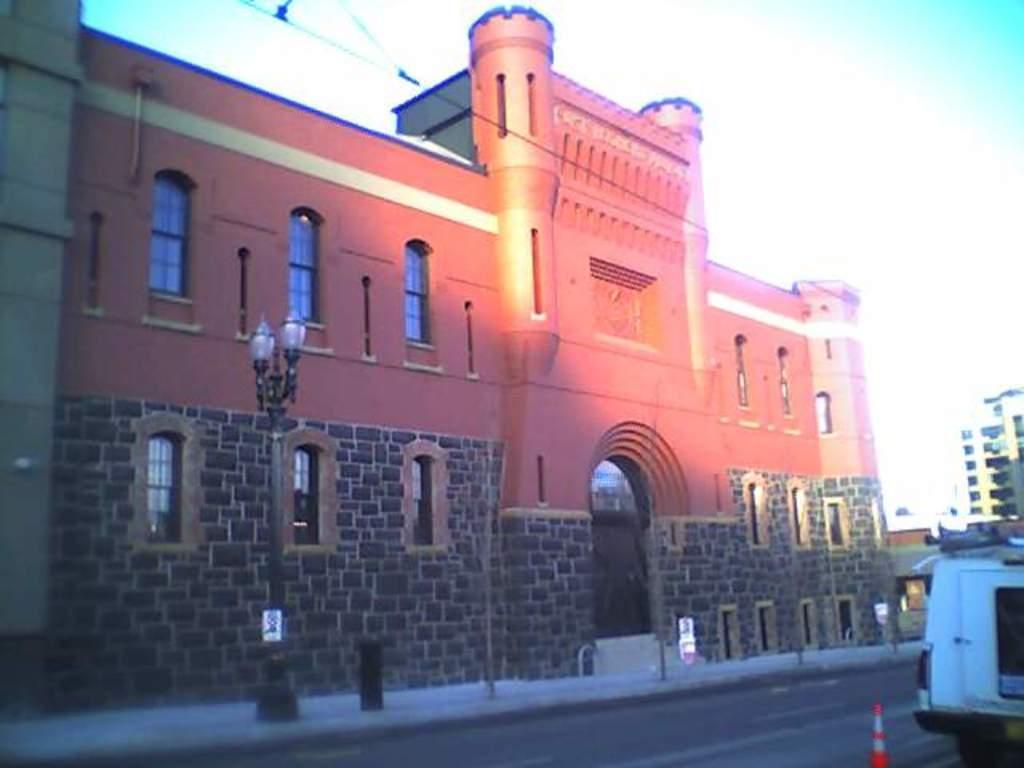Could you give a brief overview of what you see in this image? In this image I can see the road, a vehicle, the sidewalk, few poles and few buildings. In the background I can see the sky. 